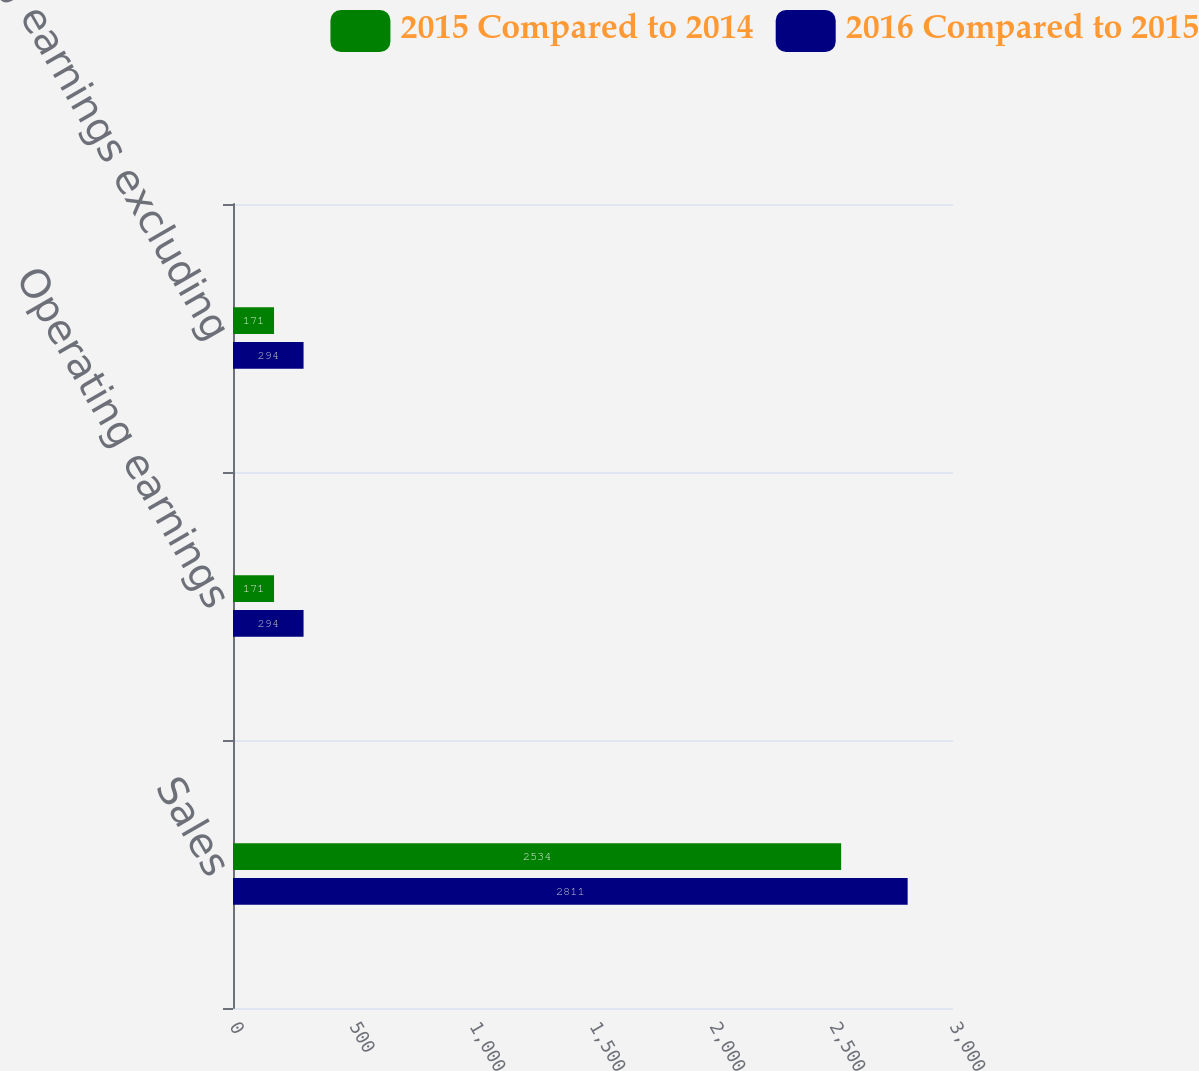Convert chart. <chart><loc_0><loc_0><loc_500><loc_500><stacked_bar_chart><ecel><fcel>Sales<fcel>Operating earnings<fcel>Operating earnings excluding<nl><fcel>2015 Compared to 2014<fcel>2534<fcel>171<fcel>171<nl><fcel>2016 Compared to 2015<fcel>2811<fcel>294<fcel>294<nl></chart> 